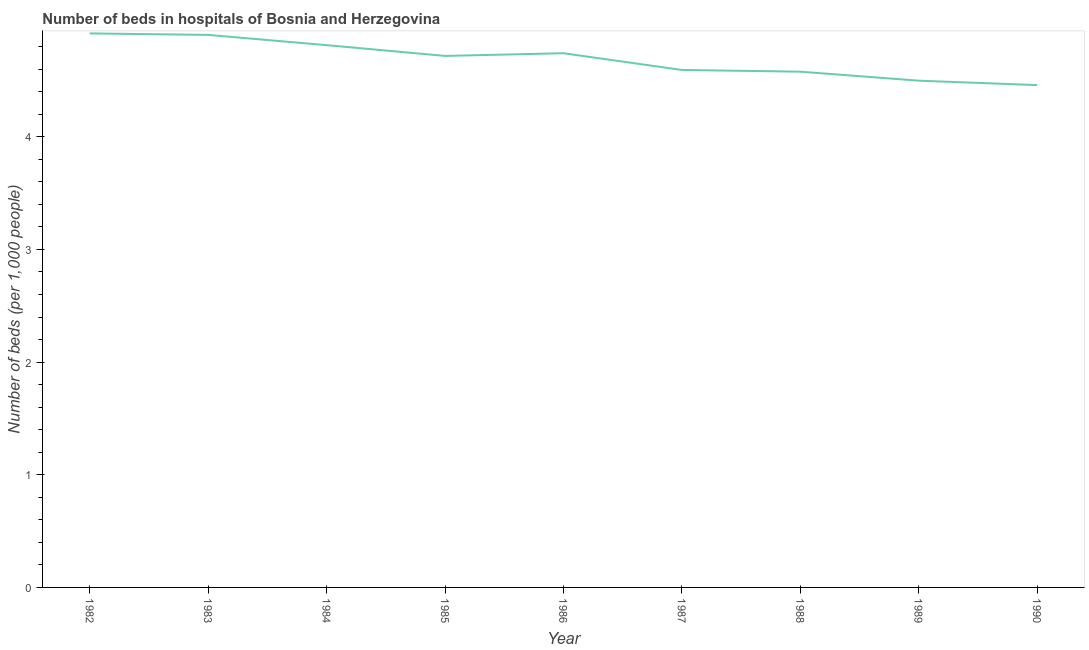What is the number of hospital beds in 1989?
Provide a succinct answer. 4.5. Across all years, what is the maximum number of hospital beds?
Give a very brief answer. 4.92. Across all years, what is the minimum number of hospital beds?
Offer a terse response. 4.46. In which year was the number of hospital beds minimum?
Your response must be concise. 1990. What is the sum of the number of hospital beds?
Provide a short and direct response. 42.23. What is the difference between the number of hospital beds in 1987 and 1990?
Give a very brief answer. 0.13. What is the average number of hospital beds per year?
Provide a succinct answer. 4.69. What is the median number of hospital beds?
Keep it short and to the point. 4.72. Do a majority of the years between 1982 and 1987 (inclusive) have number of hospital beds greater than 2.6 %?
Provide a succinct answer. Yes. What is the ratio of the number of hospital beds in 1983 to that in 1990?
Provide a succinct answer. 1.1. What is the difference between the highest and the second highest number of hospital beds?
Ensure brevity in your answer.  0.01. What is the difference between the highest and the lowest number of hospital beds?
Make the answer very short. 0.46. In how many years, is the number of hospital beds greater than the average number of hospital beds taken over all years?
Offer a very short reply. 5. How many lines are there?
Keep it short and to the point. 1. How many years are there in the graph?
Give a very brief answer. 9. Does the graph contain any zero values?
Give a very brief answer. No. Does the graph contain grids?
Your response must be concise. No. What is the title of the graph?
Your response must be concise. Number of beds in hospitals of Bosnia and Herzegovina. What is the label or title of the X-axis?
Give a very brief answer. Year. What is the label or title of the Y-axis?
Ensure brevity in your answer.  Number of beds (per 1,0 people). What is the Number of beds (per 1,000 people) in 1982?
Provide a short and direct response. 4.92. What is the Number of beds (per 1,000 people) of 1983?
Your answer should be compact. 4.9. What is the Number of beds (per 1,000 people) in 1984?
Give a very brief answer. 4.81. What is the Number of beds (per 1,000 people) of 1985?
Make the answer very short. 4.72. What is the Number of beds (per 1,000 people) of 1986?
Make the answer very short. 4.74. What is the Number of beds (per 1,000 people) of 1987?
Make the answer very short. 4.59. What is the Number of beds (per 1,000 people) in 1988?
Offer a very short reply. 4.58. What is the Number of beds (per 1,000 people) in 1989?
Your answer should be very brief. 4.5. What is the Number of beds (per 1,000 people) in 1990?
Your response must be concise. 4.46. What is the difference between the Number of beds (per 1,000 people) in 1982 and 1983?
Ensure brevity in your answer.  0.01. What is the difference between the Number of beds (per 1,000 people) in 1982 and 1984?
Offer a terse response. 0.1. What is the difference between the Number of beds (per 1,000 people) in 1982 and 1985?
Offer a very short reply. 0.2. What is the difference between the Number of beds (per 1,000 people) in 1982 and 1986?
Keep it short and to the point. 0.18. What is the difference between the Number of beds (per 1,000 people) in 1982 and 1987?
Your answer should be very brief. 0.32. What is the difference between the Number of beds (per 1,000 people) in 1982 and 1988?
Your answer should be very brief. 0.34. What is the difference between the Number of beds (per 1,000 people) in 1982 and 1989?
Provide a succinct answer. 0.42. What is the difference between the Number of beds (per 1,000 people) in 1982 and 1990?
Your response must be concise. 0.46. What is the difference between the Number of beds (per 1,000 people) in 1983 and 1984?
Offer a terse response. 0.09. What is the difference between the Number of beds (per 1,000 people) in 1983 and 1985?
Give a very brief answer. 0.19. What is the difference between the Number of beds (per 1,000 people) in 1983 and 1986?
Provide a succinct answer. 0.16. What is the difference between the Number of beds (per 1,000 people) in 1983 and 1987?
Give a very brief answer. 0.31. What is the difference between the Number of beds (per 1,000 people) in 1983 and 1988?
Ensure brevity in your answer.  0.33. What is the difference between the Number of beds (per 1,000 people) in 1983 and 1989?
Keep it short and to the point. 0.41. What is the difference between the Number of beds (per 1,000 people) in 1983 and 1990?
Make the answer very short. 0.45. What is the difference between the Number of beds (per 1,000 people) in 1984 and 1985?
Provide a succinct answer. 0.1. What is the difference between the Number of beds (per 1,000 people) in 1984 and 1986?
Your answer should be very brief. 0.07. What is the difference between the Number of beds (per 1,000 people) in 1984 and 1987?
Provide a short and direct response. 0.22. What is the difference between the Number of beds (per 1,000 people) in 1984 and 1988?
Keep it short and to the point. 0.24. What is the difference between the Number of beds (per 1,000 people) in 1984 and 1989?
Make the answer very short. 0.32. What is the difference between the Number of beds (per 1,000 people) in 1984 and 1990?
Offer a terse response. 0.35. What is the difference between the Number of beds (per 1,000 people) in 1985 and 1986?
Keep it short and to the point. -0.02. What is the difference between the Number of beds (per 1,000 people) in 1985 and 1987?
Provide a short and direct response. 0.12. What is the difference between the Number of beds (per 1,000 people) in 1985 and 1988?
Offer a very short reply. 0.14. What is the difference between the Number of beds (per 1,000 people) in 1985 and 1989?
Your answer should be compact. 0.22. What is the difference between the Number of beds (per 1,000 people) in 1985 and 1990?
Your answer should be compact. 0.26. What is the difference between the Number of beds (per 1,000 people) in 1986 and 1987?
Provide a succinct answer. 0.15. What is the difference between the Number of beds (per 1,000 people) in 1986 and 1988?
Give a very brief answer. 0.16. What is the difference between the Number of beds (per 1,000 people) in 1986 and 1989?
Provide a short and direct response. 0.24. What is the difference between the Number of beds (per 1,000 people) in 1986 and 1990?
Provide a succinct answer. 0.28. What is the difference between the Number of beds (per 1,000 people) in 1987 and 1988?
Your answer should be compact. 0.02. What is the difference between the Number of beds (per 1,000 people) in 1987 and 1989?
Your response must be concise. 0.1. What is the difference between the Number of beds (per 1,000 people) in 1987 and 1990?
Your answer should be compact. 0.13. What is the difference between the Number of beds (per 1,000 people) in 1988 and 1989?
Give a very brief answer. 0.08. What is the difference between the Number of beds (per 1,000 people) in 1988 and 1990?
Offer a terse response. 0.12. What is the difference between the Number of beds (per 1,000 people) in 1989 and 1990?
Make the answer very short. 0.04. What is the ratio of the Number of beds (per 1,000 people) in 1982 to that in 1985?
Provide a succinct answer. 1.04. What is the ratio of the Number of beds (per 1,000 people) in 1982 to that in 1987?
Provide a short and direct response. 1.07. What is the ratio of the Number of beds (per 1,000 people) in 1982 to that in 1988?
Your answer should be very brief. 1.07. What is the ratio of the Number of beds (per 1,000 people) in 1982 to that in 1989?
Make the answer very short. 1.09. What is the ratio of the Number of beds (per 1,000 people) in 1982 to that in 1990?
Your response must be concise. 1.1. What is the ratio of the Number of beds (per 1,000 people) in 1983 to that in 1985?
Offer a terse response. 1.04. What is the ratio of the Number of beds (per 1,000 people) in 1983 to that in 1986?
Your response must be concise. 1.03. What is the ratio of the Number of beds (per 1,000 people) in 1983 to that in 1987?
Give a very brief answer. 1.07. What is the ratio of the Number of beds (per 1,000 people) in 1983 to that in 1988?
Keep it short and to the point. 1.07. What is the ratio of the Number of beds (per 1,000 people) in 1983 to that in 1989?
Your answer should be compact. 1.09. What is the ratio of the Number of beds (per 1,000 people) in 1983 to that in 1990?
Offer a very short reply. 1.1. What is the ratio of the Number of beds (per 1,000 people) in 1984 to that in 1985?
Make the answer very short. 1.02. What is the ratio of the Number of beds (per 1,000 people) in 1984 to that in 1986?
Give a very brief answer. 1.01. What is the ratio of the Number of beds (per 1,000 people) in 1984 to that in 1987?
Provide a short and direct response. 1.05. What is the ratio of the Number of beds (per 1,000 people) in 1984 to that in 1988?
Your answer should be compact. 1.05. What is the ratio of the Number of beds (per 1,000 people) in 1984 to that in 1989?
Keep it short and to the point. 1.07. What is the ratio of the Number of beds (per 1,000 people) in 1985 to that in 1986?
Give a very brief answer. 0.99. What is the ratio of the Number of beds (per 1,000 people) in 1985 to that in 1988?
Offer a very short reply. 1.03. What is the ratio of the Number of beds (per 1,000 people) in 1985 to that in 1989?
Your response must be concise. 1.05. What is the ratio of the Number of beds (per 1,000 people) in 1985 to that in 1990?
Give a very brief answer. 1.06. What is the ratio of the Number of beds (per 1,000 people) in 1986 to that in 1987?
Ensure brevity in your answer.  1.03. What is the ratio of the Number of beds (per 1,000 people) in 1986 to that in 1988?
Your response must be concise. 1.04. What is the ratio of the Number of beds (per 1,000 people) in 1986 to that in 1989?
Make the answer very short. 1.05. What is the ratio of the Number of beds (per 1,000 people) in 1986 to that in 1990?
Make the answer very short. 1.06. What is the ratio of the Number of beds (per 1,000 people) in 1987 to that in 1989?
Your response must be concise. 1.02. What is the ratio of the Number of beds (per 1,000 people) in 1988 to that in 1990?
Ensure brevity in your answer.  1.03. 